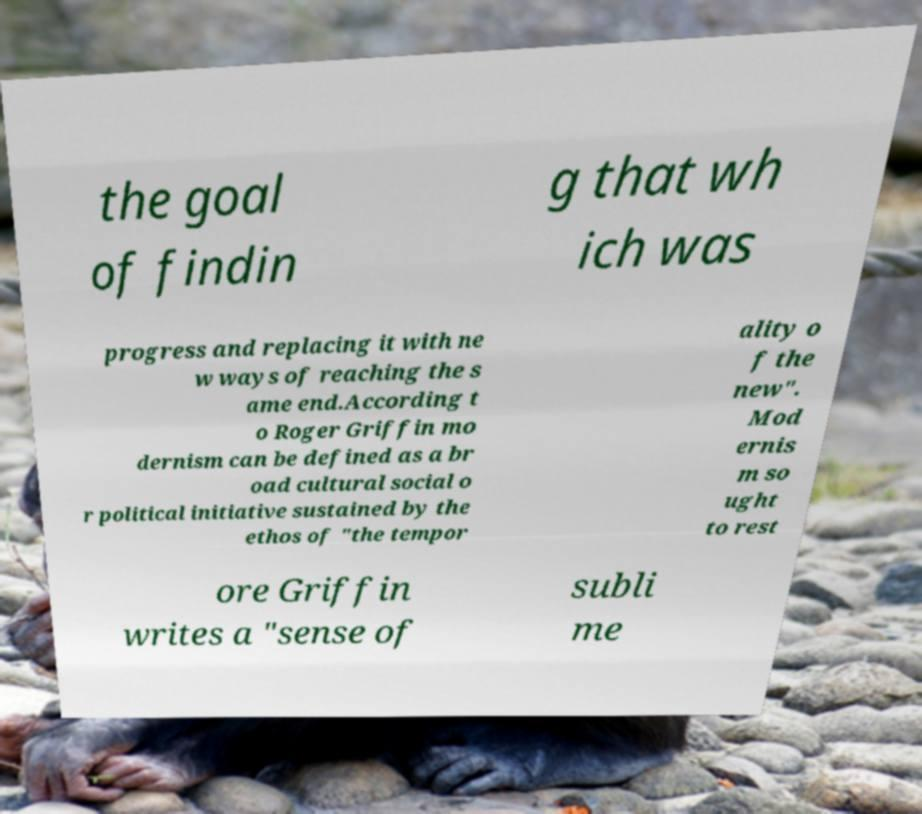Can you accurately transcribe the text from the provided image for me? the goal of findin g that wh ich was progress and replacing it with ne w ways of reaching the s ame end.According t o Roger Griffin mo dernism can be defined as a br oad cultural social o r political initiative sustained by the ethos of "the tempor ality o f the new". Mod ernis m so ught to rest ore Griffin writes a "sense of subli me 